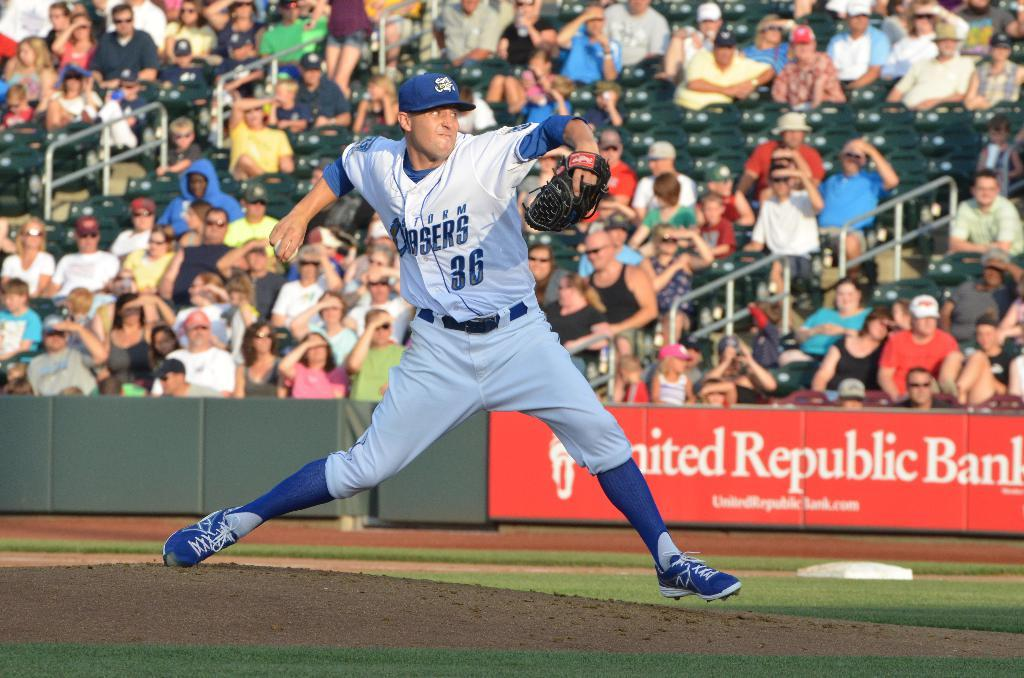<image>
Share a concise interpretation of the image provided. A baseball player in the field is wearing a storm chaser jersey 